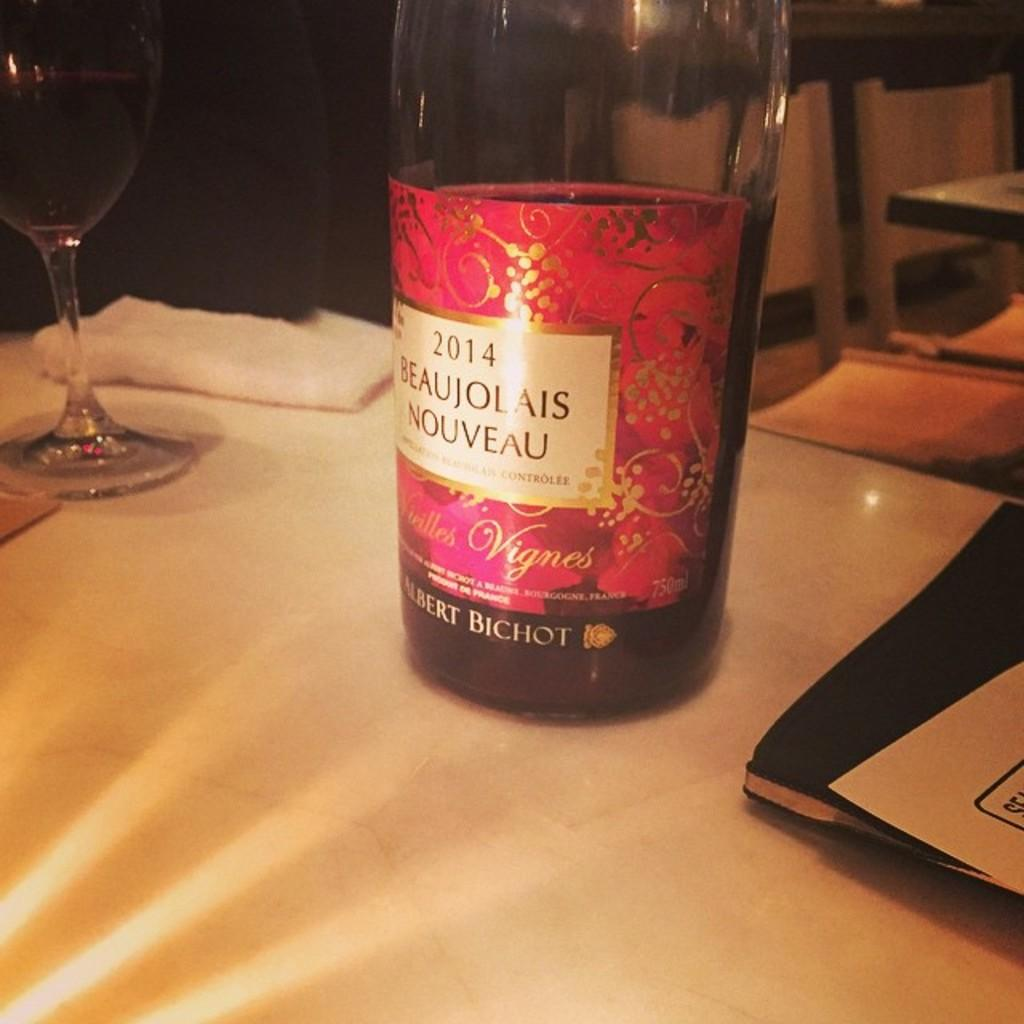What is in the bottle that is visible in the image? There is a bottle with a label in the image. What can be seen on the table in the image? There is a glass on the table in the image. How many balls are visible in the image? There are no balls present in the image. What type of yard is shown in the image? There is no yard present in the image; it only features a bottle and a glass. 